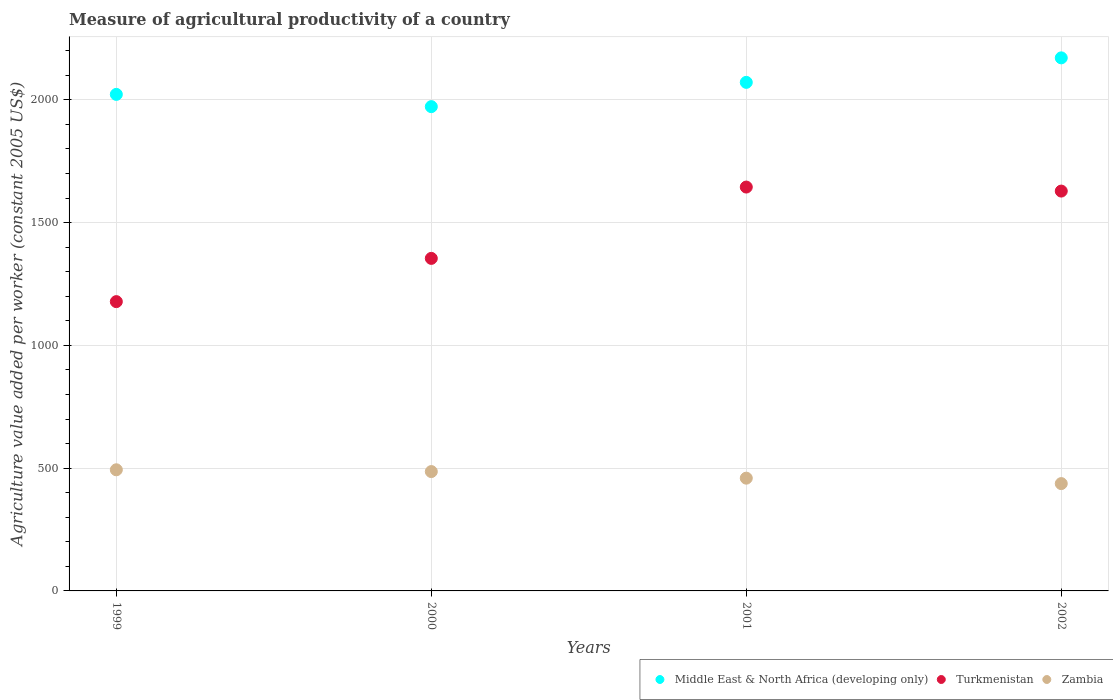What is the measure of agricultural productivity in Turkmenistan in 2000?
Ensure brevity in your answer.  1354.24. Across all years, what is the maximum measure of agricultural productivity in Turkmenistan?
Offer a terse response. 1644.73. Across all years, what is the minimum measure of agricultural productivity in Turkmenistan?
Give a very brief answer. 1178.14. In which year was the measure of agricultural productivity in Middle East & North Africa (developing only) minimum?
Ensure brevity in your answer.  2000. What is the total measure of agricultural productivity in Turkmenistan in the graph?
Make the answer very short. 5805.45. What is the difference between the measure of agricultural productivity in Turkmenistan in 1999 and that in 2002?
Your response must be concise. -450.2. What is the difference between the measure of agricultural productivity in Zambia in 2001 and the measure of agricultural productivity in Turkmenistan in 2000?
Your answer should be very brief. -895.03. What is the average measure of agricultural productivity in Middle East & North Africa (developing only) per year?
Give a very brief answer. 2059.08. In the year 2000, what is the difference between the measure of agricultural productivity in Zambia and measure of agricultural productivity in Middle East & North Africa (developing only)?
Your answer should be very brief. -1486.23. In how many years, is the measure of agricultural productivity in Turkmenistan greater than 1100 US$?
Provide a short and direct response. 4. What is the ratio of the measure of agricultural productivity in Middle East & North Africa (developing only) in 1999 to that in 2001?
Provide a succinct answer. 0.98. Is the measure of agricultural productivity in Turkmenistan in 2000 less than that in 2002?
Give a very brief answer. Yes. Is the difference between the measure of agricultural productivity in Zambia in 1999 and 2001 greater than the difference between the measure of agricultural productivity in Middle East & North Africa (developing only) in 1999 and 2001?
Provide a short and direct response. Yes. What is the difference between the highest and the second highest measure of agricultural productivity in Turkmenistan?
Your answer should be compact. 16.39. What is the difference between the highest and the lowest measure of agricultural productivity in Middle East & North Africa (developing only)?
Your answer should be compact. 198.62. In how many years, is the measure of agricultural productivity in Turkmenistan greater than the average measure of agricultural productivity in Turkmenistan taken over all years?
Your answer should be compact. 2. Does the measure of agricultural productivity in Zambia monotonically increase over the years?
Make the answer very short. No. Is the measure of agricultural productivity in Zambia strictly less than the measure of agricultural productivity in Turkmenistan over the years?
Make the answer very short. Yes. How many years are there in the graph?
Offer a terse response. 4. Does the graph contain any zero values?
Ensure brevity in your answer.  No. How many legend labels are there?
Offer a terse response. 3. How are the legend labels stacked?
Your response must be concise. Horizontal. What is the title of the graph?
Offer a terse response. Measure of agricultural productivity of a country. What is the label or title of the X-axis?
Offer a terse response. Years. What is the label or title of the Y-axis?
Provide a short and direct response. Agriculture value added per worker (constant 2005 US$). What is the Agriculture value added per worker (constant 2005 US$) in Middle East & North Africa (developing only) in 1999?
Make the answer very short. 2022.12. What is the Agriculture value added per worker (constant 2005 US$) in Turkmenistan in 1999?
Provide a succinct answer. 1178.14. What is the Agriculture value added per worker (constant 2005 US$) in Zambia in 1999?
Your response must be concise. 493.31. What is the Agriculture value added per worker (constant 2005 US$) of Middle East & North Africa (developing only) in 2000?
Offer a very short reply. 1972.26. What is the Agriculture value added per worker (constant 2005 US$) of Turkmenistan in 2000?
Keep it short and to the point. 1354.24. What is the Agriculture value added per worker (constant 2005 US$) of Zambia in 2000?
Offer a terse response. 486.03. What is the Agriculture value added per worker (constant 2005 US$) in Middle East & North Africa (developing only) in 2001?
Your answer should be compact. 2071.08. What is the Agriculture value added per worker (constant 2005 US$) of Turkmenistan in 2001?
Keep it short and to the point. 1644.73. What is the Agriculture value added per worker (constant 2005 US$) in Zambia in 2001?
Provide a succinct answer. 459.21. What is the Agriculture value added per worker (constant 2005 US$) in Middle East & North Africa (developing only) in 2002?
Offer a very short reply. 2170.88. What is the Agriculture value added per worker (constant 2005 US$) of Turkmenistan in 2002?
Provide a succinct answer. 1628.34. What is the Agriculture value added per worker (constant 2005 US$) of Zambia in 2002?
Offer a very short reply. 437.08. Across all years, what is the maximum Agriculture value added per worker (constant 2005 US$) in Middle East & North Africa (developing only)?
Ensure brevity in your answer.  2170.88. Across all years, what is the maximum Agriculture value added per worker (constant 2005 US$) in Turkmenistan?
Offer a terse response. 1644.73. Across all years, what is the maximum Agriculture value added per worker (constant 2005 US$) of Zambia?
Give a very brief answer. 493.31. Across all years, what is the minimum Agriculture value added per worker (constant 2005 US$) in Middle East & North Africa (developing only)?
Offer a very short reply. 1972.26. Across all years, what is the minimum Agriculture value added per worker (constant 2005 US$) of Turkmenistan?
Provide a succinct answer. 1178.14. Across all years, what is the minimum Agriculture value added per worker (constant 2005 US$) of Zambia?
Make the answer very short. 437.08. What is the total Agriculture value added per worker (constant 2005 US$) in Middle East & North Africa (developing only) in the graph?
Provide a succinct answer. 8236.33. What is the total Agriculture value added per worker (constant 2005 US$) of Turkmenistan in the graph?
Keep it short and to the point. 5805.45. What is the total Agriculture value added per worker (constant 2005 US$) in Zambia in the graph?
Your answer should be very brief. 1875.63. What is the difference between the Agriculture value added per worker (constant 2005 US$) in Middle East & North Africa (developing only) in 1999 and that in 2000?
Offer a terse response. 49.86. What is the difference between the Agriculture value added per worker (constant 2005 US$) in Turkmenistan in 1999 and that in 2000?
Give a very brief answer. -176.1. What is the difference between the Agriculture value added per worker (constant 2005 US$) of Zambia in 1999 and that in 2000?
Make the answer very short. 7.29. What is the difference between the Agriculture value added per worker (constant 2005 US$) of Middle East & North Africa (developing only) in 1999 and that in 2001?
Offer a very short reply. -48.96. What is the difference between the Agriculture value added per worker (constant 2005 US$) of Turkmenistan in 1999 and that in 2001?
Your response must be concise. -466.59. What is the difference between the Agriculture value added per worker (constant 2005 US$) of Zambia in 1999 and that in 2001?
Your answer should be compact. 34.11. What is the difference between the Agriculture value added per worker (constant 2005 US$) in Middle East & North Africa (developing only) in 1999 and that in 2002?
Offer a very short reply. -148.76. What is the difference between the Agriculture value added per worker (constant 2005 US$) in Turkmenistan in 1999 and that in 2002?
Provide a short and direct response. -450.2. What is the difference between the Agriculture value added per worker (constant 2005 US$) in Zambia in 1999 and that in 2002?
Make the answer very short. 56.23. What is the difference between the Agriculture value added per worker (constant 2005 US$) in Middle East & North Africa (developing only) in 2000 and that in 2001?
Keep it short and to the point. -98.82. What is the difference between the Agriculture value added per worker (constant 2005 US$) of Turkmenistan in 2000 and that in 2001?
Make the answer very short. -290.49. What is the difference between the Agriculture value added per worker (constant 2005 US$) in Zambia in 2000 and that in 2001?
Make the answer very short. 26.82. What is the difference between the Agriculture value added per worker (constant 2005 US$) of Middle East & North Africa (developing only) in 2000 and that in 2002?
Give a very brief answer. -198.62. What is the difference between the Agriculture value added per worker (constant 2005 US$) in Turkmenistan in 2000 and that in 2002?
Your answer should be very brief. -274.1. What is the difference between the Agriculture value added per worker (constant 2005 US$) of Zambia in 2000 and that in 2002?
Your answer should be compact. 48.95. What is the difference between the Agriculture value added per worker (constant 2005 US$) of Middle East & North Africa (developing only) in 2001 and that in 2002?
Your answer should be very brief. -99.8. What is the difference between the Agriculture value added per worker (constant 2005 US$) in Turkmenistan in 2001 and that in 2002?
Offer a very short reply. 16.39. What is the difference between the Agriculture value added per worker (constant 2005 US$) of Zambia in 2001 and that in 2002?
Your response must be concise. 22.13. What is the difference between the Agriculture value added per worker (constant 2005 US$) in Middle East & North Africa (developing only) in 1999 and the Agriculture value added per worker (constant 2005 US$) in Turkmenistan in 2000?
Offer a terse response. 667.88. What is the difference between the Agriculture value added per worker (constant 2005 US$) in Middle East & North Africa (developing only) in 1999 and the Agriculture value added per worker (constant 2005 US$) in Zambia in 2000?
Provide a short and direct response. 1536.09. What is the difference between the Agriculture value added per worker (constant 2005 US$) of Turkmenistan in 1999 and the Agriculture value added per worker (constant 2005 US$) of Zambia in 2000?
Provide a short and direct response. 692.11. What is the difference between the Agriculture value added per worker (constant 2005 US$) in Middle East & North Africa (developing only) in 1999 and the Agriculture value added per worker (constant 2005 US$) in Turkmenistan in 2001?
Provide a short and direct response. 377.39. What is the difference between the Agriculture value added per worker (constant 2005 US$) of Middle East & North Africa (developing only) in 1999 and the Agriculture value added per worker (constant 2005 US$) of Zambia in 2001?
Provide a succinct answer. 1562.91. What is the difference between the Agriculture value added per worker (constant 2005 US$) of Turkmenistan in 1999 and the Agriculture value added per worker (constant 2005 US$) of Zambia in 2001?
Offer a terse response. 718.93. What is the difference between the Agriculture value added per worker (constant 2005 US$) in Middle East & North Africa (developing only) in 1999 and the Agriculture value added per worker (constant 2005 US$) in Turkmenistan in 2002?
Make the answer very short. 393.78. What is the difference between the Agriculture value added per worker (constant 2005 US$) of Middle East & North Africa (developing only) in 1999 and the Agriculture value added per worker (constant 2005 US$) of Zambia in 2002?
Ensure brevity in your answer.  1585.04. What is the difference between the Agriculture value added per worker (constant 2005 US$) of Turkmenistan in 1999 and the Agriculture value added per worker (constant 2005 US$) of Zambia in 2002?
Offer a terse response. 741.06. What is the difference between the Agriculture value added per worker (constant 2005 US$) of Middle East & North Africa (developing only) in 2000 and the Agriculture value added per worker (constant 2005 US$) of Turkmenistan in 2001?
Provide a short and direct response. 327.53. What is the difference between the Agriculture value added per worker (constant 2005 US$) in Middle East & North Africa (developing only) in 2000 and the Agriculture value added per worker (constant 2005 US$) in Zambia in 2001?
Your answer should be very brief. 1513.05. What is the difference between the Agriculture value added per worker (constant 2005 US$) in Turkmenistan in 2000 and the Agriculture value added per worker (constant 2005 US$) in Zambia in 2001?
Ensure brevity in your answer.  895.03. What is the difference between the Agriculture value added per worker (constant 2005 US$) in Middle East & North Africa (developing only) in 2000 and the Agriculture value added per worker (constant 2005 US$) in Turkmenistan in 2002?
Give a very brief answer. 343.91. What is the difference between the Agriculture value added per worker (constant 2005 US$) in Middle East & North Africa (developing only) in 2000 and the Agriculture value added per worker (constant 2005 US$) in Zambia in 2002?
Offer a very short reply. 1535.18. What is the difference between the Agriculture value added per worker (constant 2005 US$) in Turkmenistan in 2000 and the Agriculture value added per worker (constant 2005 US$) in Zambia in 2002?
Offer a very short reply. 917.16. What is the difference between the Agriculture value added per worker (constant 2005 US$) in Middle East & North Africa (developing only) in 2001 and the Agriculture value added per worker (constant 2005 US$) in Turkmenistan in 2002?
Keep it short and to the point. 442.74. What is the difference between the Agriculture value added per worker (constant 2005 US$) of Middle East & North Africa (developing only) in 2001 and the Agriculture value added per worker (constant 2005 US$) of Zambia in 2002?
Make the answer very short. 1634. What is the difference between the Agriculture value added per worker (constant 2005 US$) in Turkmenistan in 2001 and the Agriculture value added per worker (constant 2005 US$) in Zambia in 2002?
Your response must be concise. 1207.65. What is the average Agriculture value added per worker (constant 2005 US$) of Middle East & North Africa (developing only) per year?
Give a very brief answer. 2059.08. What is the average Agriculture value added per worker (constant 2005 US$) in Turkmenistan per year?
Your answer should be very brief. 1451.36. What is the average Agriculture value added per worker (constant 2005 US$) of Zambia per year?
Provide a short and direct response. 468.91. In the year 1999, what is the difference between the Agriculture value added per worker (constant 2005 US$) of Middle East & North Africa (developing only) and Agriculture value added per worker (constant 2005 US$) of Turkmenistan?
Your answer should be very brief. 843.98. In the year 1999, what is the difference between the Agriculture value added per worker (constant 2005 US$) of Middle East & North Africa (developing only) and Agriculture value added per worker (constant 2005 US$) of Zambia?
Provide a succinct answer. 1528.81. In the year 1999, what is the difference between the Agriculture value added per worker (constant 2005 US$) of Turkmenistan and Agriculture value added per worker (constant 2005 US$) of Zambia?
Your response must be concise. 684.83. In the year 2000, what is the difference between the Agriculture value added per worker (constant 2005 US$) in Middle East & North Africa (developing only) and Agriculture value added per worker (constant 2005 US$) in Turkmenistan?
Give a very brief answer. 618.02. In the year 2000, what is the difference between the Agriculture value added per worker (constant 2005 US$) of Middle East & North Africa (developing only) and Agriculture value added per worker (constant 2005 US$) of Zambia?
Your answer should be compact. 1486.23. In the year 2000, what is the difference between the Agriculture value added per worker (constant 2005 US$) of Turkmenistan and Agriculture value added per worker (constant 2005 US$) of Zambia?
Keep it short and to the point. 868.21. In the year 2001, what is the difference between the Agriculture value added per worker (constant 2005 US$) in Middle East & North Africa (developing only) and Agriculture value added per worker (constant 2005 US$) in Turkmenistan?
Your response must be concise. 426.35. In the year 2001, what is the difference between the Agriculture value added per worker (constant 2005 US$) of Middle East & North Africa (developing only) and Agriculture value added per worker (constant 2005 US$) of Zambia?
Keep it short and to the point. 1611.87. In the year 2001, what is the difference between the Agriculture value added per worker (constant 2005 US$) in Turkmenistan and Agriculture value added per worker (constant 2005 US$) in Zambia?
Give a very brief answer. 1185.52. In the year 2002, what is the difference between the Agriculture value added per worker (constant 2005 US$) in Middle East & North Africa (developing only) and Agriculture value added per worker (constant 2005 US$) in Turkmenistan?
Give a very brief answer. 542.54. In the year 2002, what is the difference between the Agriculture value added per worker (constant 2005 US$) of Middle East & North Africa (developing only) and Agriculture value added per worker (constant 2005 US$) of Zambia?
Provide a succinct answer. 1733.8. In the year 2002, what is the difference between the Agriculture value added per worker (constant 2005 US$) of Turkmenistan and Agriculture value added per worker (constant 2005 US$) of Zambia?
Your answer should be very brief. 1191.26. What is the ratio of the Agriculture value added per worker (constant 2005 US$) in Middle East & North Africa (developing only) in 1999 to that in 2000?
Your response must be concise. 1.03. What is the ratio of the Agriculture value added per worker (constant 2005 US$) of Turkmenistan in 1999 to that in 2000?
Your response must be concise. 0.87. What is the ratio of the Agriculture value added per worker (constant 2005 US$) in Middle East & North Africa (developing only) in 1999 to that in 2001?
Keep it short and to the point. 0.98. What is the ratio of the Agriculture value added per worker (constant 2005 US$) in Turkmenistan in 1999 to that in 2001?
Give a very brief answer. 0.72. What is the ratio of the Agriculture value added per worker (constant 2005 US$) in Zambia in 1999 to that in 2001?
Provide a short and direct response. 1.07. What is the ratio of the Agriculture value added per worker (constant 2005 US$) of Middle East & North Africa (developing only) in 1999 to that in 2002?
Keep it short and to the point. 0.93. What is the ratio of the Agriculture value added per worker (constant 2005 US$) in Turkmenistan in 1999 to that in 2002?
Offer a terse response. 0.72. What is the ratio of the Agriculture value added per worker (constant 2005 US$) of Zambia in 1999 to that in 2002?
Keep it short and to the point. 1.13. What is the ratio of the Agriculture value added per worker (constant 2005 US$) in Middle East & North Africa (developing only) in 2000 to that in 2001?
Make the answer very short. 0.95. What is the ratio of the Agriculture value added per worker (constant 2005 US$) of Turkmenistan in 2000 to that in 2001?
Offer a very short reply. 0.82. What is the ratio of the Agriculture value added per worker (constant 2005 US$) of Zambia in 2000 to that in 2001?
Offer a very short reply. 1.06. What is the ratio of the Agriculture value added per worker (constant 2005 US$) in Middle East & North Africa (developing only) in 2000 to that in 2002?
Ensure brevity in your answer.  0.91. What is the ratio of the Agriculture value added per worker (constant 2005 US$) of Turkmenistan in 2000 to that in 2002?
Your response must be concise. 0.83. What is the ratio of the Agriculture value added per worker (constant 2005 US$) of Zambia in 2000 to that in 2002?
Ensure brevity in your answer.  1.11. What is the ratio of the Agriculture value added per worker (constant 2005 US$) of Middle East & North Africa (developing only) in 2001 to that in 2002?
Make the answer very short. 0.95. What is the ratio of the Agriculture value added per worker (constant 2005 US$) in Turkmenistan in 2001 to that in 2002?
Ensure brevity in your answer.  1.01. What is the ratio of the Agriculture value added per worker (constant 2005 US$) of Zambia in 2001 to that in 2002?
Your response must be concise. 1.05. What is the difference between the highest and the second highest Agriculture value added per worker (constant 2005 US$) in Middle East & North Africa (developing only)?
Offer a very short reply. 99.8. What is the difference between the highest and the second highest Agriculture value added per worker (constant 2005 US$) in Turkmenistan?
Your answer should be compact. 16.39. What is the difference between the highest and the second highest Agriculture value added per worker (constant 2005 US$) in Zambia?
Keep it short and to the point. 7.29. What is the difference between the highest and the lowest Agriculture value added per worker (constant 2005 US$) of Middle East & North Africa (developing only)?
Provide a succinct answer. 198.62. What is the difference between the highest and the lowest Agriculture value added per worker (constant 2005 US$) of Turkmenistan?
Ensure brevity in your answer.  466.59. What is the difference between the highest and the lowest Agriculture value added per worker (constant 2005 US$) of Zambia?
Your answer should be compact. 56.23. 